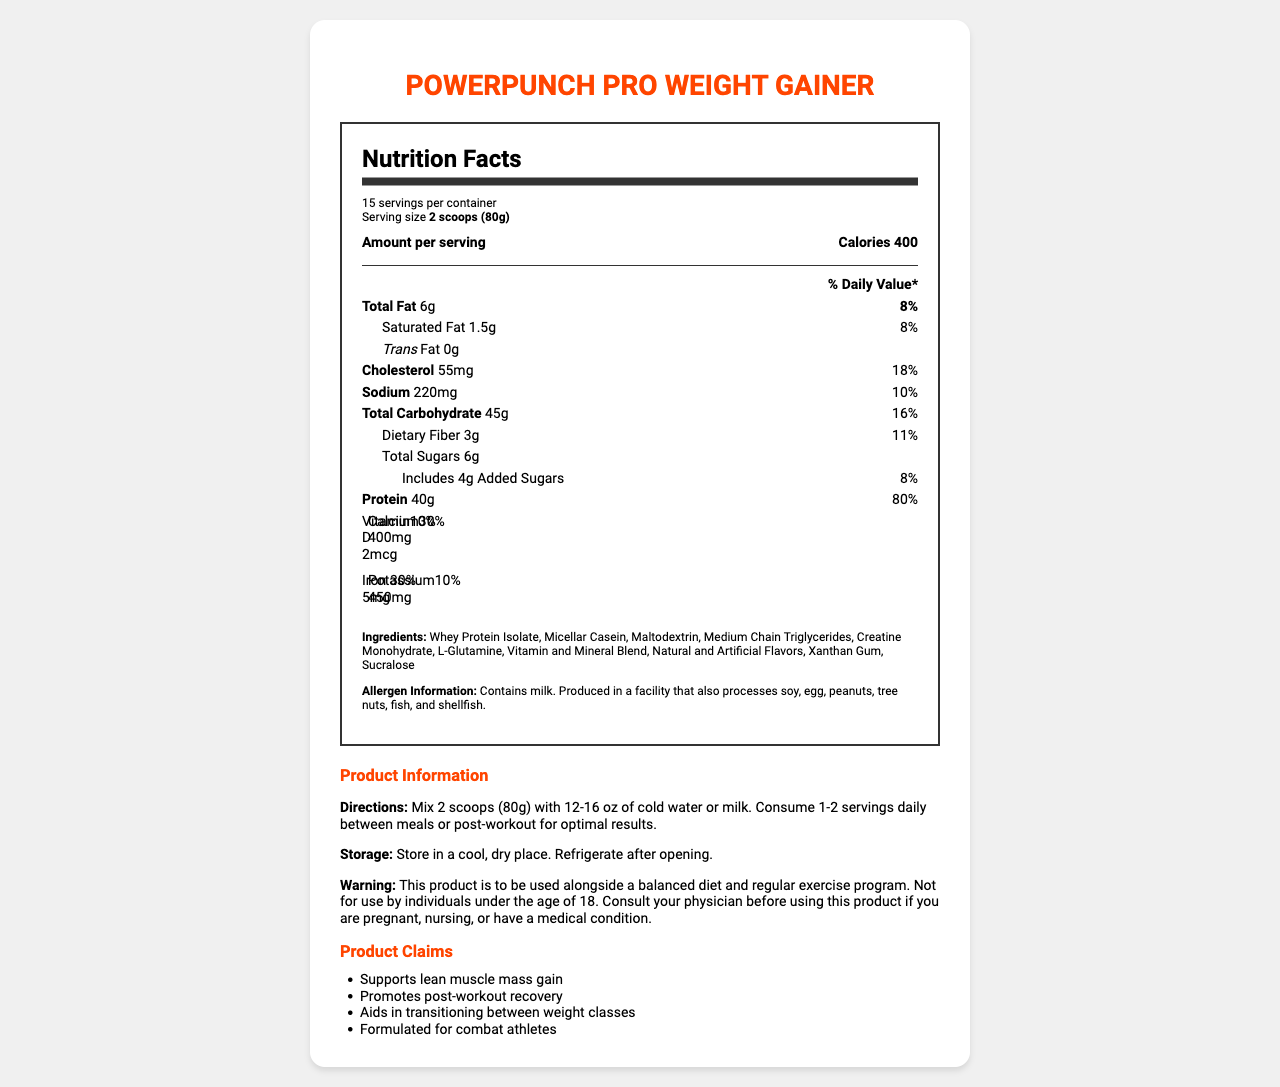How many servings are there per container? The document specifies that there are 15 servings per container.
Answer: 15 What is the amount of protein per serving? The document states that each serving contains 40g of protein.
Answer: 40g How much calcium is in one serving? The document lists 400mg of calcium per serving.
Answer: 400mg What percentage of the daily value of iron does one serving provide? The document shows that one serving provides 30% of the daily value of iron.
Answer: 30% List three primary ingredients included in the PowerPunch Pro Weight Gainer. The document lists these as part of the ingredients.
Answer: Whey Protein Isolate, Micellar Casein, Maltodextrin Which of the following claims is NOT made about the PowerPunch Pro Weight Gainer? A. Supports lean muscle mass gain B. Aids in transitioning between weight classes C. Contains zero fat D. Promotes post-workout recovery The document does not claim that the product contains zero fat.
Answer: C What is the recommended serving size according to the directions? A. 1 scoop (40g) B. 2 scoops (80g) C. 3 scoops (120g) D. 4 scoops (160g) The recommended serving size in the document is 2 scoops (80g).
Answer: B Does the product contain any vitamin D? The document specifies that each serving contains 2mcg of vitamin D.
Answer: Yes Summarize the key nutritional features and usage instructions for the PowerPunch Pro Weight Gainer. This summary captures the main nutritional features and recommended usage instructions detailed in the document.
Answer: The PowerPunch Pro Weight Gainer is designed to support lean muscle mass gain and post-workout recovery. Each serving (2 scoops, 80g) provides 400 calories, 40g of protein, 6g of total fat, 45g of carbohydrates, and various vitamins and minerals. The product should be mixed with 12-16 oz of water or milk and consumed 1-2 times daily between meals or post-workout. What is the creatine content in one serving? The document does not provide specific information about the creatine content in one serving.
Answer: Cannot be determined 